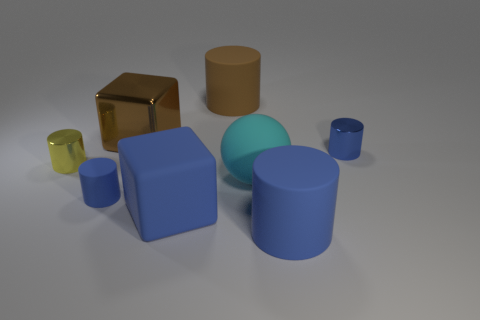Subtract all brown spheres. How many blue cylinders are left? 3 Subtract 1 cylinders. How many cylinders are left? 4 Subtract all yellow cylinders. How many cylinders are left? 4 Subtract all gray cylinders. Subtract all blue balls. How many cylinders are left? 5 Add 1 tiny red cylinders. How many objects exist? 9 Subtract all cylinders. How many objects are left? 3 Subtract all large cyan shiny spheres. Subtract all large brown cubes. How many objects are left? 7 Add 3 large blue cylinders. How many large blue cylinders are left? 4 Add 5 large brown cylinders. How many large brown cylinders exist? 6 Subtract 1 cyan spheres. How many objects are left? 7 